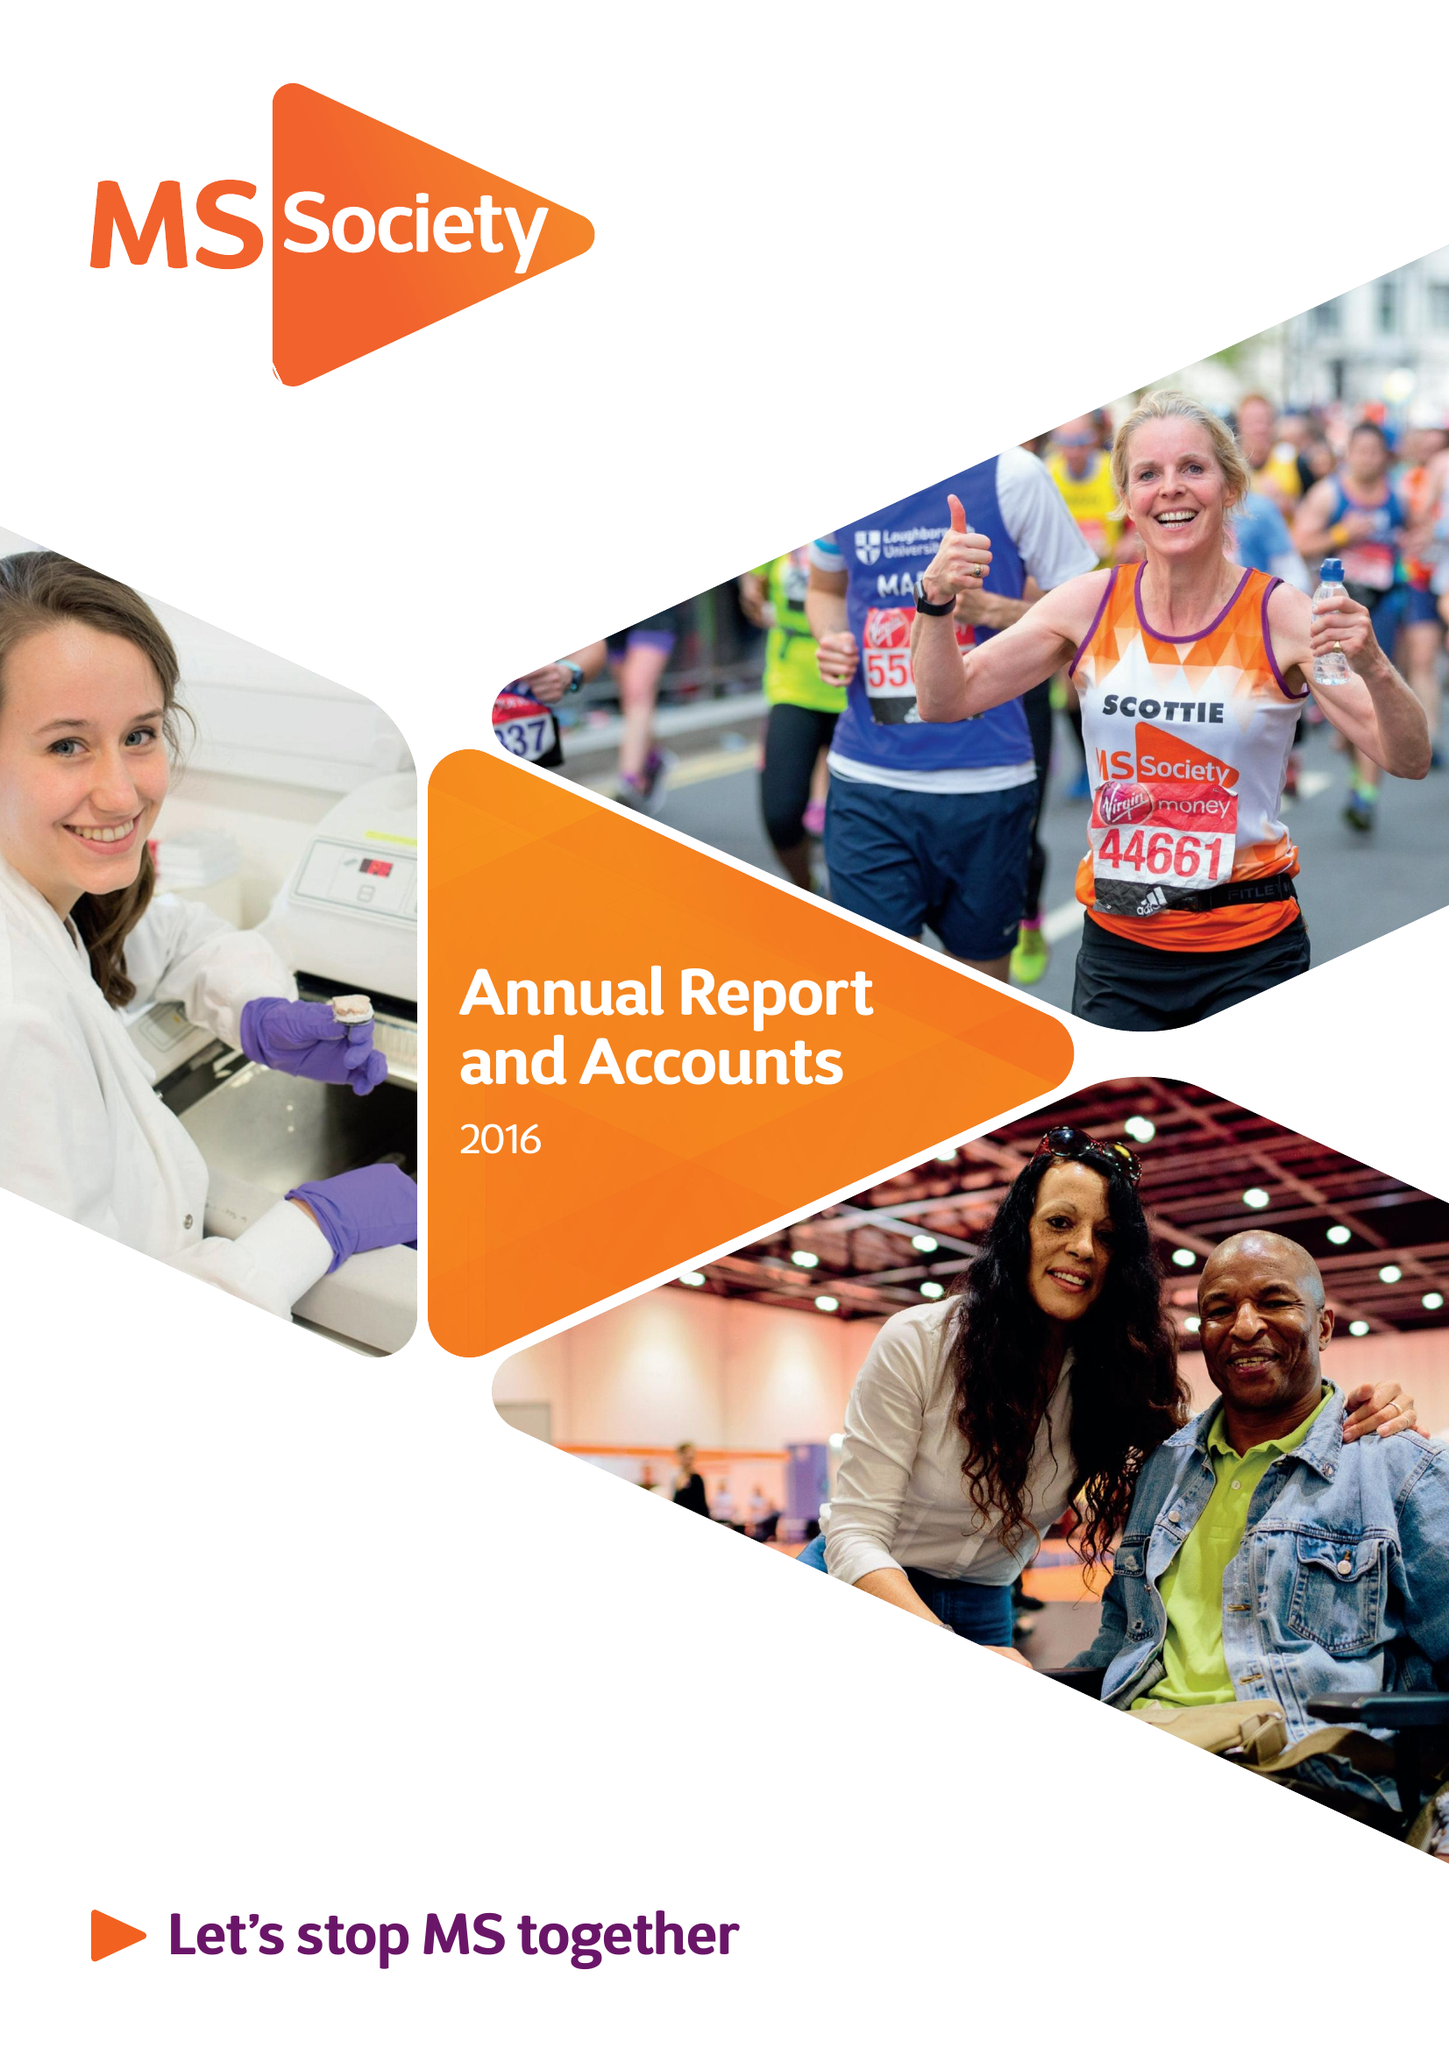What is the value for the report_date?
Answer the question using a single word or phrase. 2016-12-31 